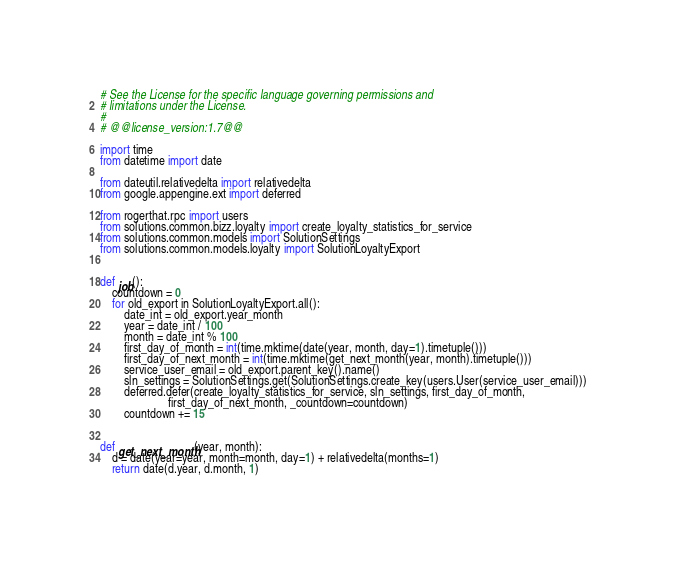Convert code to text. <code><loc_0><loc_0><loc_500><loc_500><_Python_># See the License for the specific language governing permissions and
# limitations under the License.
#
# @@license_version:1.7@@

import time
from datetime import date

from dateutil.relativedelta import relativedelta
from google.appengine.ext import deferred

from rogerthat.rpc import users
from solutions.common.bizz.loyalty import create_loyalty_statistics_for_service
from solutions.common.models import SolutionSettings
from solutions.common.models.loyalty import SolutionLoyaltyExport


def job():
    countdown = 0
    for old_export in SolutionLoyaltyExport.all():
        date_int = old_export.year_month
        year = date_int / 100
        month = date_int % 100
        first_day_of_month = int(time.mktime(date(year, month, day=1).timetuple()))
        first_day_of_next_month = int(time.mktime(get_next_month(year, month).timetuple()))
        service_user_email = old_export.parent_key().name()
        sln_settings = SolutionSettings.get(SolutionSettings.create_key(users.User(service_user_email)))
        deferred.defer(create_loyalty_statistics_for_service, sln_settings, first_day_of_month,
                       first_day_of_next_month, _countdown=countdown)
        countdown += 15


def get_next_month(year, month):
    d = date(year=year, month=month, day=1) + relativedelta(months=1)
    return date(d.year, d.month, 1)
</code> 